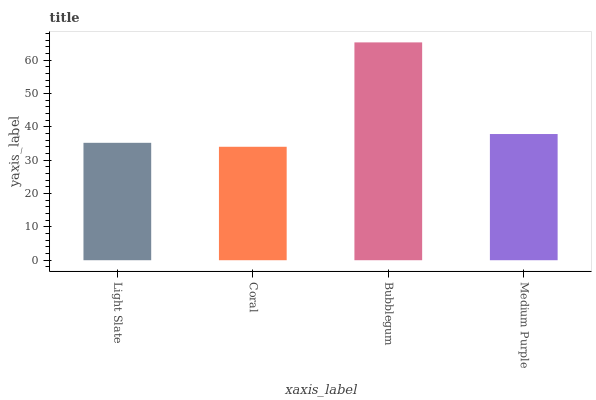Is Coral the minimum?
Answer yes or no. Yes. Is Bubblegum the maximum?
Answer yes or no. Yes. Is Bubblegum the minimum?
Answer yes or no. No. Is Coral the maximum?
Answer yes or no. No. Is Bubblegum greater than Coral?
Answer yes or no. Yes. Is Coral less than Bubblegum?
Answer yes or no. Yes. Is Coral greater than Bubblegum?
Answer yes or no. No. Is Bubblegum less than Coral?
Answer yes or no. No. Is Medium Purple the high median?
Answer yes or no. Yes. Is Light Slate the low median?
Answer yes or no. Yes. Is Coral the high median?
Answer yes or no. No. Is Coral the low median?
Answer yes or no. No. 